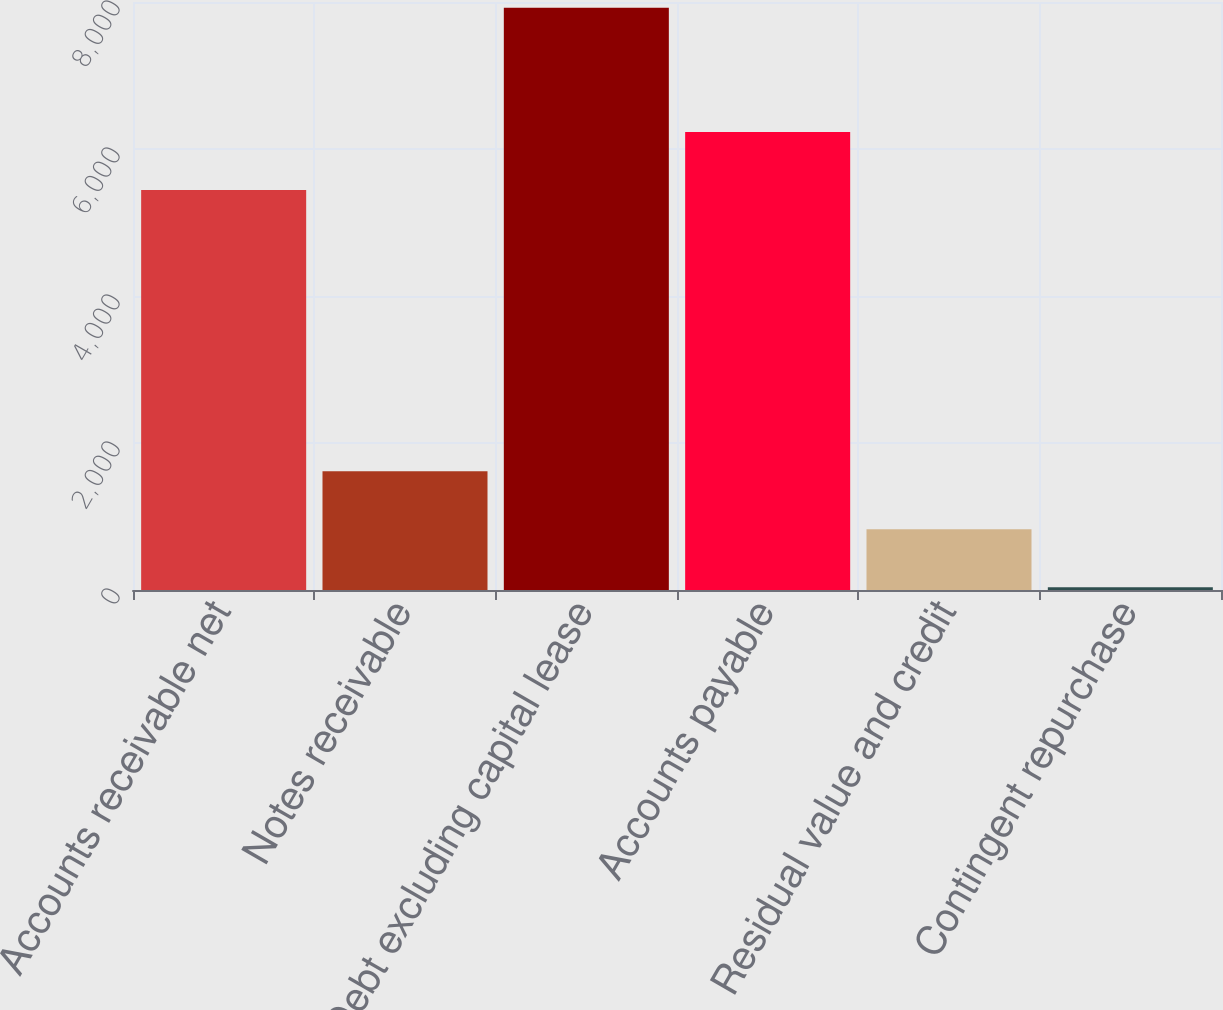Convert chart to OTSL. <chart><loc_0><loc_0><loc_500><loc_500><bar_chart><fcel>Accounts receivable net<fcel>Notes receivable<fcel>Debt excluding capital lease<fcel>Accounts payable<fcel>Residual value and credit<fcel>Contingent repurchase<nl><fcel>5443<fcel>1615<fcel>7923<fcel>6231.5<fcel>826.5<fcel>38<nl></chart> 